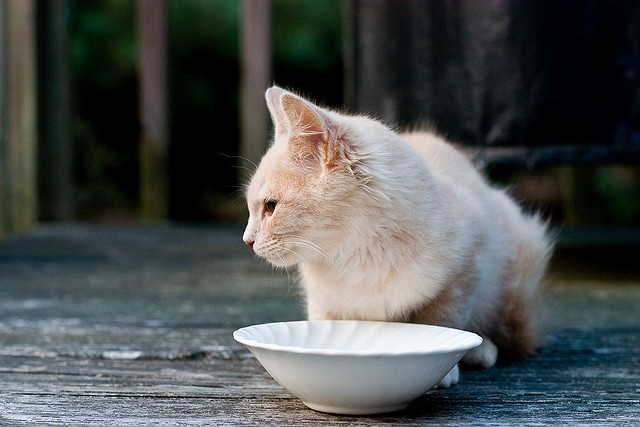Describe the objects in this image and their specific colors. I can see cat in gray, darkgray, tan, and lightgray tones and bowl in gray, lightgray, and darkgray tones in this image. 